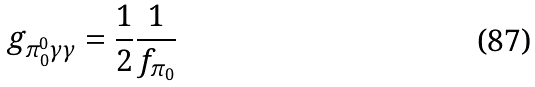Convert formula to latex. <formula><loc_0><loc_0><loc_500><loc_500>g _ { \pi _ { 0 } ^ { 0 } \gamma \gamma } = \frac { 1 } { 2 } \frac { 1 } { f _ { \pi _ { 0 } } }</formula> 